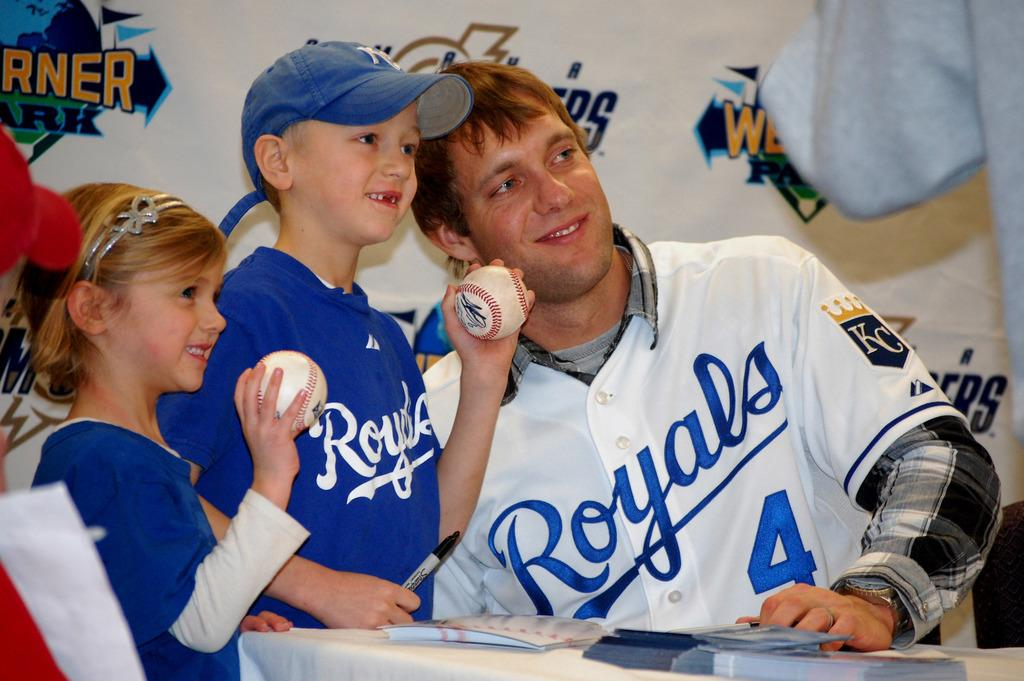<image>
Summarize the visual content of the image. A Royals player takes pictures with fans and signs autographs 